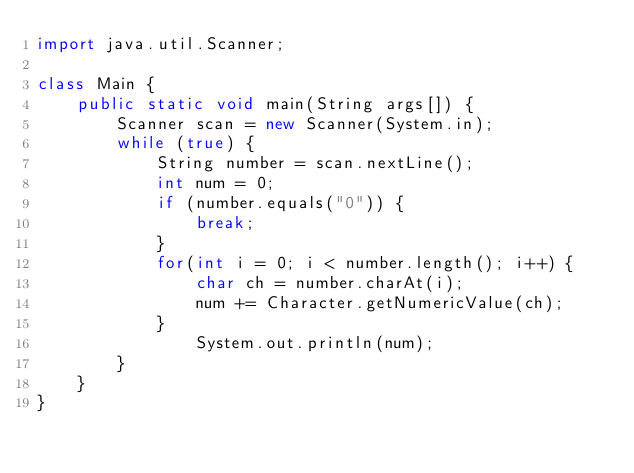Convert code to text. <code><loc_0><loc_0><loc_500><loc_500><_Java_>import java.util.Scanner;

class Main {
    public static void main(String args[]) {
        Scanner scan = new Scanner(System.in);
        while (true) {
            String number = scan.nextLine();
            int num = 0;
            if (number.equals("0")) {
                break;
            }
            for(int i = 0; i < number.length(); i++) {
                char ch = number.charAt(i);
                num += Character.getNumericValue(ch);
            }
                System.out.println(num);
        }
    }
}</code> 